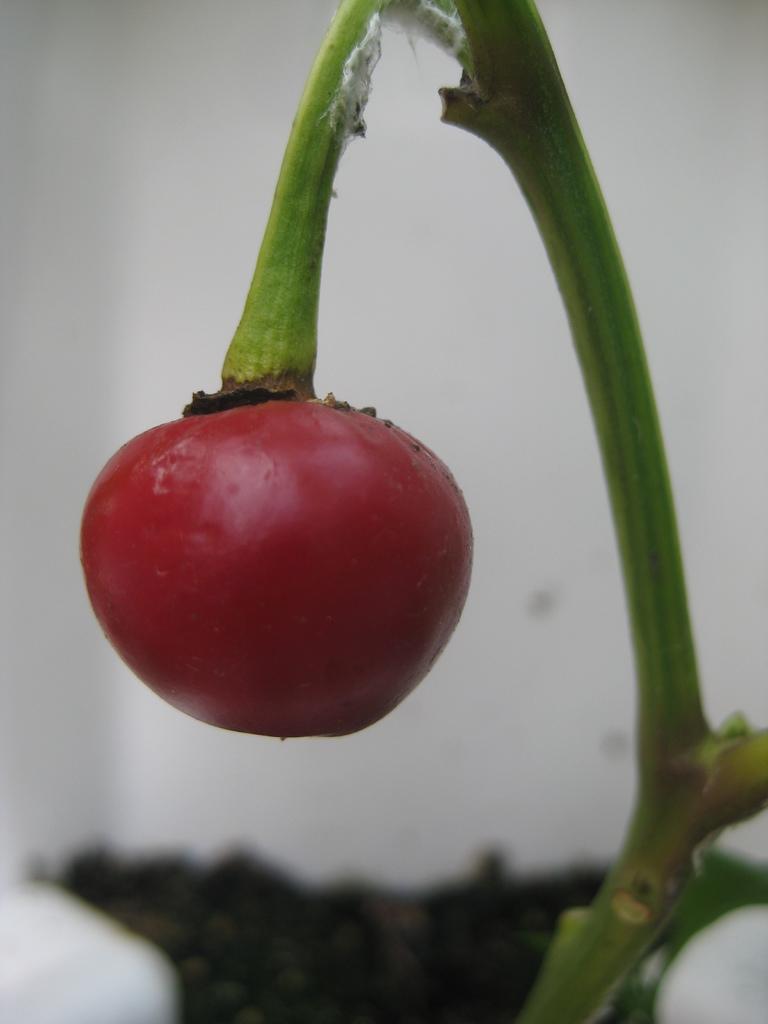Could you give a brief overview of what you see in this image? This image is taken outdoors. In the background there is a wall. At the bottom of the image there is soil. In the middle of the image there is a plant and there is a fruit which is red in color. 